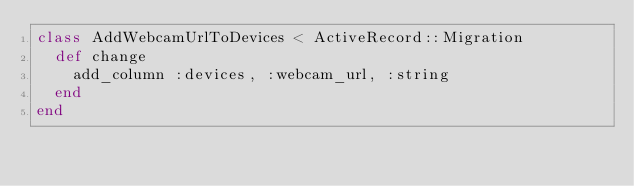<code> <loc_0><loc_0><loc_500><loc_500><_Ruby_>class AddWebcamUrlToDevices < ActiveRecord::Migration
  def change
    add_column :devices, :webcam_url, :string
  end
end
</code> 